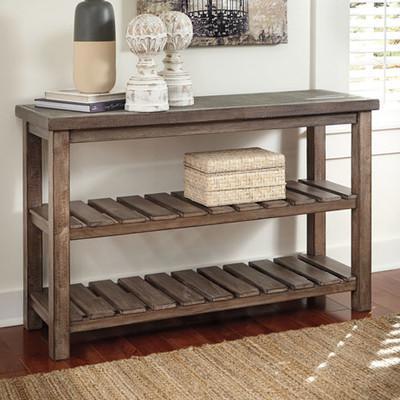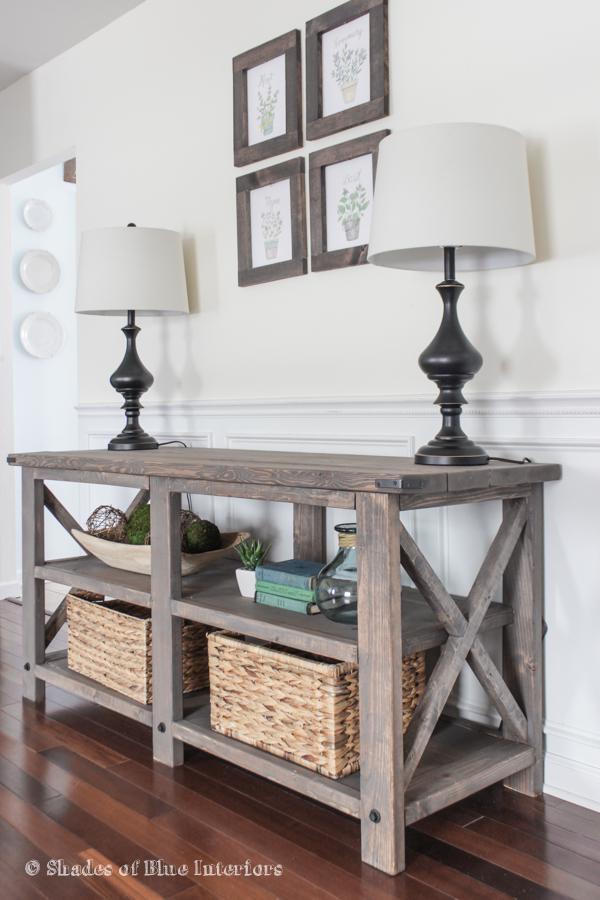The first image is the image on the left, the second image is the image on the right. Given the left and right images, does the statement "A TV with a black screen is hanging on a white wall." hold true? Answer yes or no. No. 